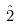<formula> <loc_0><loc_0><loc_500><loc_500>\hat { 2 }</formula> 